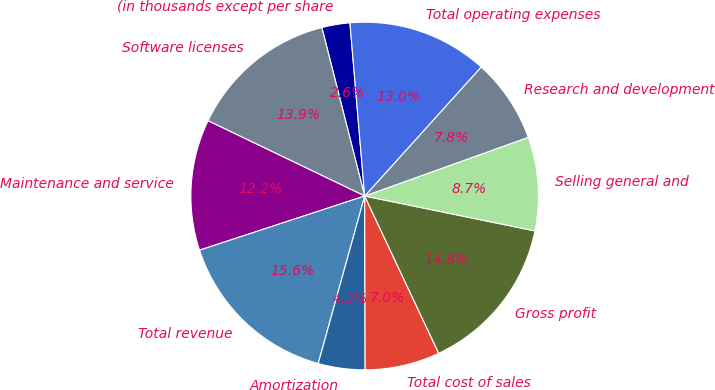Convert chart. <chart><loc_0><loc_0><loc_500><loc_500><pie_chart><fcel>(in thousands except per share<fcel>Software licenses<fcel>Maintenance and service<fcel>Total revenue<fcel>Amortization<fcel>Total cost of sales<fcel>Gross profit<fcel>Selling general and<fcel>Research and development<fcel>Total operating expenses<nl><fcel>2.61%<fcel>13.91%<fcel>12.17%<fcel>15.65%<fcel>4.35%<fcel>6.96%<fcel>14.78%<fcel>8.7%<fcel>7.83%<fcel>13.04%<nl></chart> 